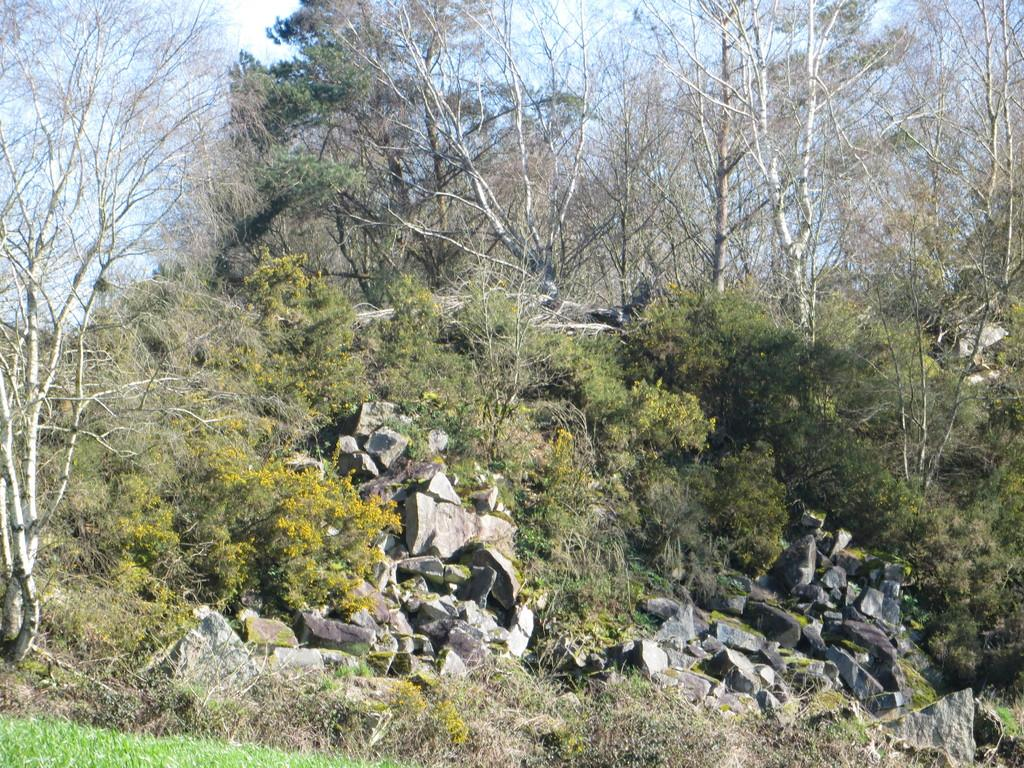What type of natural elements can be seen in the image? There are rocks, plants, and trees in the image. Where are the rocks, plants, and trees located? They are on a hill. What is visible above the hill in the image? The sky is visible above the hill. Where is the market located in the image? There is no market present in the image. Can you see a badge on any of the rocks in the image? There is no badge visible on any of the rocks in the image. 